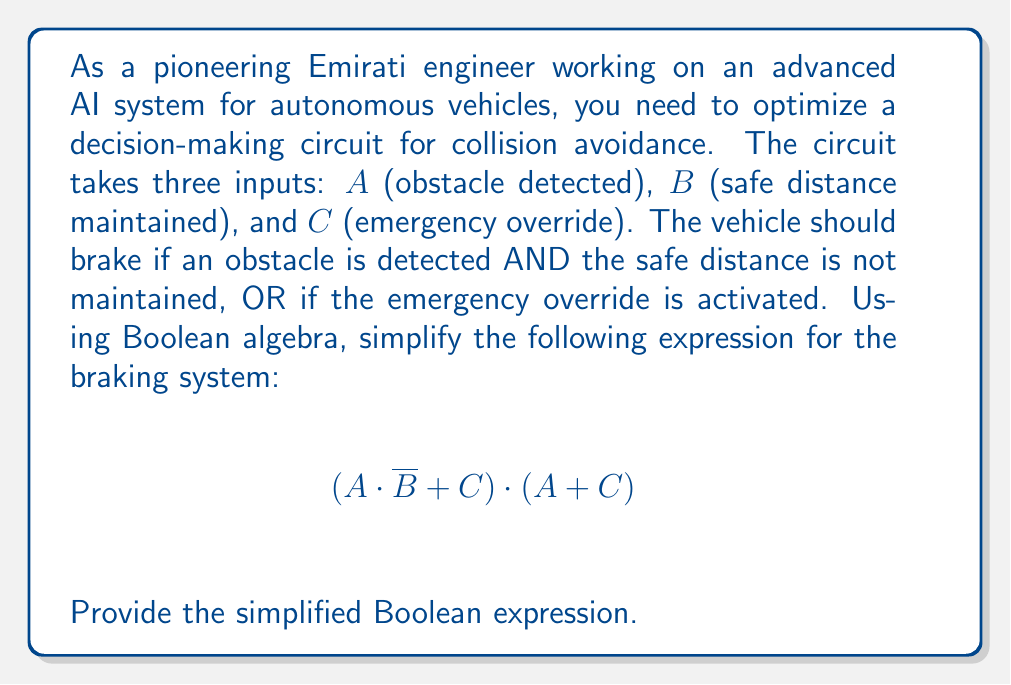What is the answer to this math problem? Let's simplify this Boolean expression step by step using Boolean algebra laws:

1) Start with the given expression: $$(A \cdot \overline{B} + C) \cdot (A + C)$$

2) Apply the distributive law:
   $$(A \cdot \overline{B} \cdot A) + (A \cdot \overline{B} \cdot C) + (C \cdot A) + (C \cdot C)$$

3) Simplify $A \cdot A = A$ (idempotent law):
   $$(A \cdot \overline{B}) + (A \cdot \overline{B} \cdot C) + (C \cdot A) + C$$

4) In the second term, $A \cdot \overline{B} \cdot C$ is absorbed by $C \cdot A$ (absorption law):
   $$(A \cdot \overline{B}) + (C \cdot A) + C$$

5) Apply the distributive law again:
   $$(A \cdot \overline{B}) + (C \cdot (A + 1))$$

6) Simplify $A + 1 = 1$ (identity law):
   $$(A \cdot \overline{B}) + C$$

This is the most simplified form of the expression.
Answer: $A \cdot \overline{B} + C$ 